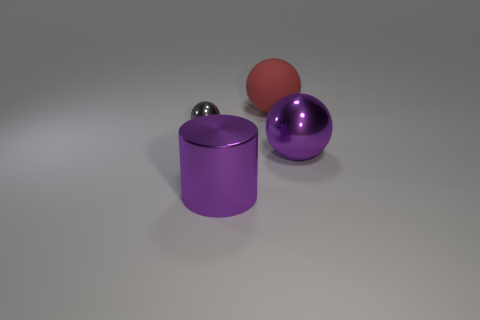There is a purple thing that is the same shape as the big red rubber object; what material is it?
Offer a terse response. Metal. What is the color of the big metallic object that is the same shape as the big red rubber thing?
Offer a very short reply. Purple. There is a metallic object on the right side of the big red object; is it the same color as the shiny object that is to the left of the metallic cylinder?
Your answer should be very brief. No. Is the number of red objects in front of the tiny thing less than the number of large purple shiny objects on the left side of the large purple ball?
Make the answer very short. Yes. What is the shape of the big object that is behind the tiny ball?
Offer a very short reply. Sphere. What is the material of the sphere that is the same color as the large cylinder?
Give a very brief answer. Metal. How many other things are there of the same material as the red sphere?
Your response must be concise. 0. Do the small gray object and the big shiny object on the left side of the red ball have the same shape?
Provide a succinct answer. No. What is the shape of the purple thing that is made of the same material as the purple sphere?
Keep it short and to the point. Cylinder. Are there more large red balls that are on the left side of the gray metal thing than small gray metallic things in front of the purple shiny cylinder?
Your answer should be compact. No. 